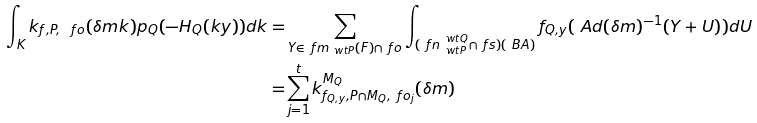Convert formula to latex. <formula><loc_0><loc_0><loc_500><loc_500>\int _ { K } k _ { f , P , \ f o } ( \delta m k ) p _ { Q } ( - H _ { Q } ( k y ) ) d k = & \sum _ { Y \in \ f m _ { \ w t { P } } ( F ) \cap \ f o } \int _ { ( \ f n _ { \ w t { P } } ^ { \ w t { Q } } \cap \ f s ) ( \ B A ) } f _ { Q , y } ( \ A d ( \delta m ) ^ { - 1 } ( Y + U ) ) d U \\ = & \sum _ { j = 1 } ^ { t } k _ { f _ { Q , y } , P \cap M _ { Q } , \ f o _ { j } } ^ { M _ { Q } } ( \delta m )</formula> 